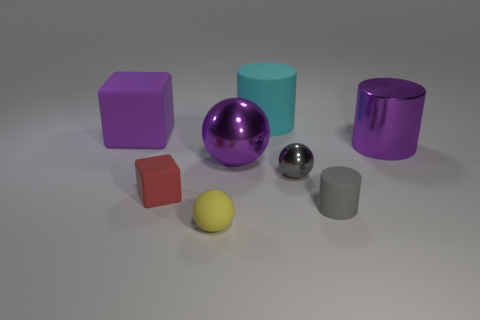How many other things are the same color as the tiny matte ball?
Offer a terse response. 0. What number of objects have the same color as the tiny matte ball?
Make the answer very short. 0. What shape is the tiny object that is both right of the small yellow matte sphere and behind the small gray matte cylinder?
Your response must be concise. Sphere. Are there more brown rubber spheres than big rubber objects?
Provide a succinct answer. No. What is the material of the small block?
Give a very brief answer. Rubber. There is a red matte object that is the same shape as the large purple rubber object; what size is it?
Your answer should be very brief. Small. There is a big shiny object that is on the right side of the small gray rubber cylinder; is there a gray shiny thing that is to the left of it?
Make the answer very short. Yes. Is the color of the tiny metallic sphere the same as the tiny rubber cylinder?
Provide a short and direct response. Yes. What number of other things are there of the same shape as the tiny red thing?
Ensure brevity in your answer.  1. Is the number of tiny objects to the left of the purple ball greater than the number of red things behind the tiny red matte thing?
Offer a terse response. Yes. 